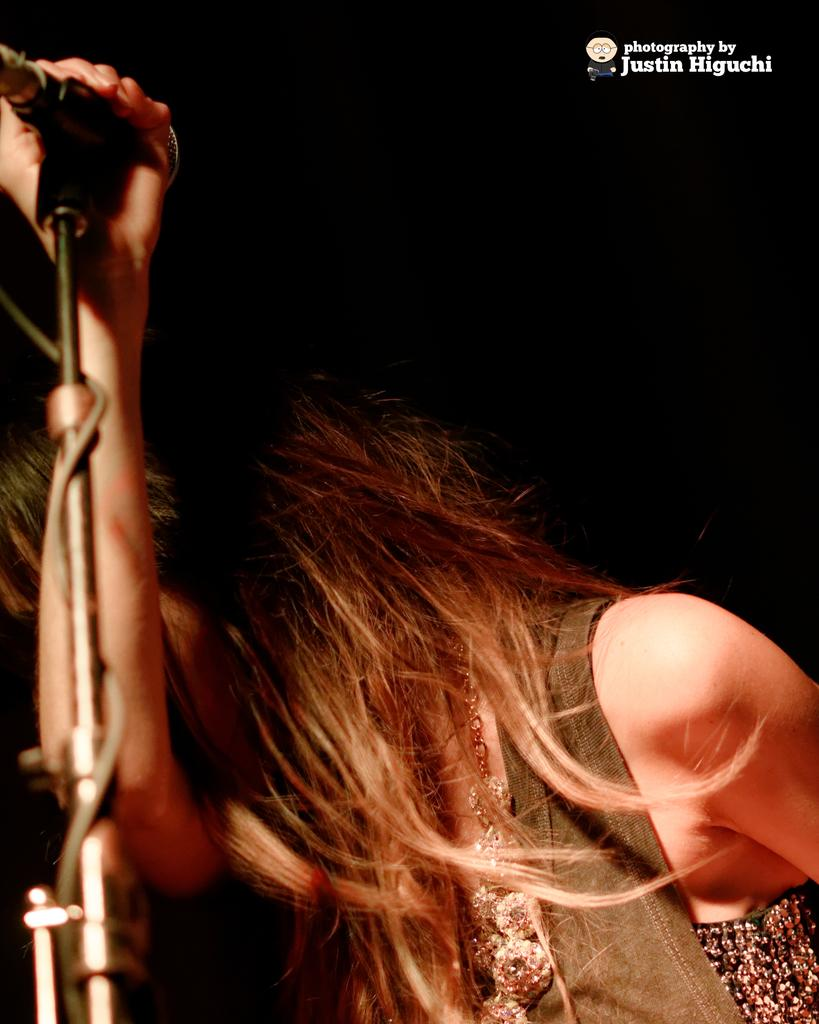Who is the main subject in the image? There is a woman in the center of the image. What is the woman doing in the image? The woman is standing and holding a microphone. What is the woman wearing in the image? The woman is wearing a jacket. What type of liquid is the woman pouring from the microphone in the image? There is no liquid present in the image, and the woman is not pouring anything from the microphone. 